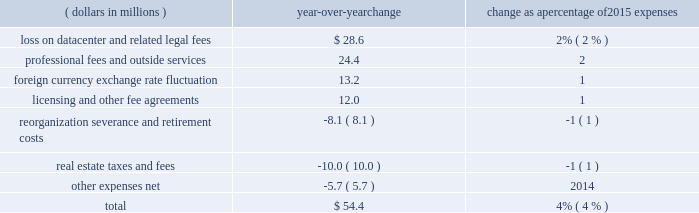Recognized total losses and expenses of $ 28.6 million , including a net loss on write-down to fair value of the assets and certain other transaction fees of $ 27.1 million within other expenses and $ 1.5 million of legal and other fees .
2022 professional fees and outside services expense decreased in 2017 compared to 2016 , largely due to higher legal and regulatory fees in 2016 related to our business activities and product offerings as well as higher professional fees related to a greater reliance on consultants for security and systems enhancement work .
The overall decrease in operating expenses in 2017 when compared with 2016 was partially offset by the following increases : 2022 licensing and other fee sharing agreements expense increased due to higher expense resulting from incentive payments made to facilitate the transition of the russell contract open interest , as well as increased costs of revenue sharing agreements for certain licensed products .
The overall increase in 2017 was partially offset by lower expense related to revenue sharing agreements for certain equity and energy contracts due to lower volume for these products compared to 2016 .
2022 compensation and benefits expense increased as a result of higher average headcount primarily in our international locations as well as normal cost of living adjustments .
2016 compared with 2015 operating expenses increased by $ 54.4 million in 2016 when compared with 2015 .
The table shows the estimated impact of key factors resulting in the net decrease in operating expenses .
( dollars in millions ) over-year change change as a percentage of 2015 expenses .
Overall operating expenses increased in 2016 when compared with 2015 due to the following reasons : 2022 in 2016 , we recognized total losses and expenses of $ 28.6 million , including a net loss on write-down to fair value of the assets and certain other transaction fees of $ 27.1 million within other expenses and $ 1.5 million of legal and other fees as a result of our sale and leaseback of our datacenter .
2022 professional fees and outside services expense increased in 2016 largely due to an increase in legal and regulatory efforts related to our business activities and product offerings as well as an increase in professional fees related to a greater reliance on consultants for security and systems enhancement work .
2022 in 2016 , we recognized a net loss of $ 24.5 million due to an unfavorable change in exchange rates on foreign cash balances , compared with a net loss of $ 11.3 million in 2015 .
2022 licensing and other fee sharing agreements expense increased due to higher expense related to revenue sharing agreements for certain equity and energy contracts due to both higher volume and an increase in license rates for certain equity and energy products. .
The loss on datacenter and related legal fees are how much of the total year over year change in expenses? 
Computations: (28.6 / 54.4)
Answer: 0.52574. Recognized total losses and expenses of $ 28.6 million , including a net loss on write-down to fair value of the assets and certain other transaction fees of $ 27.1 million within other expenses and $ 1.5 million of legal and other fees .
2022 professional fees and outside services expense decreased in 2017 compared to 2016 , largely due to higher legal and regulatory fees in 2016 related to our business activities and product offerings as well as higher professional fees related to a greater reliance on consultants for security and systems enhancement work .
The overall decrease in operating expenses in 2017 when compared with 2016 was partially offset by the following increases : 2022 licensing and other fee sharing agreements expense increased due to higher expense resulting from incentive payments made to facilitate the transition of the russell contract open interest , as well as increased costs of revenue sharing agreements for certain licensed products .
The overall increase in 2017 was partially offset by lower expense related to revenue sharing agreements for certain equity and energy contracts due to lower volume for these products compared to 2016 .
2022 compensation and benefits expense increased as a result of higher average headcount primarily in our international locations as well as normal cost of living adjustments .
2016 compared with 2015 operating expenses increased by $ 54.4 million in 2016 when compared with 2015 .
The table shows the estimated impact of key factors resulting in the net decrease in operating expenses .
( dollars in millions ) over-year change change as a percentage of 2015 expenses .
Overall operating expenses increased in 2016 when compared with 2015 due to the following reasons : 2022 in 2016 , we recognized total losses and expenses of $ 28.6 million , including a net loss on write-down to fair value of the assets and certain other transaction fees of $ 27.1 million within other expenses and $ 1.5 million of legal and other fees as a result of our sale and leaseback of our datacenter .
2022 professional fees and outside services expense increased in 2016 largely due to an increase in legal and regulatory efforts related to our business activities and product offerings as well as an increase in professional fees related to a greater reliance on consultants for security and systems enhancement work .
2022 in 2016 , we recognized a net loss of $ 24.5 million due to an unfavorable change in exchange rates on foreign cash balances , compared with a net loss of $ 11.3 million in 2015 .
2022 licensing and other fee sharing agreements expense increased due to higher expense related to revenue sharing agreements for certain equity and energy contracts due to both higher volume and an increase in license rates for certain equity and energy products. .
Increased license costs are how much of the total year over year cost increases? 
Computations: (12.0 / 54.4)
Answer: 0.22059. Recognized total losses and expenses of $ 28.6 million , including a net loss on write-down to fair value of the assets and certain other transaction fees of $ 27.1 million within other expenses and $ 1.5 million of legal and other fees .
2022 professional fees and outside services expense decreased in 2017 compared to 2016 , largely due to higher legal and regulatory fees in 2016 related to our business activities and product offerings as well as higher professional fees related to a greater reliance on consultants for security and systems enhancement work .
The overall decrease in operating expenses in 2017 when compared with 2016 was partially offset by the following increases : 2022 licensing and other fee sharing agreements expense increased due to higher expense resulting from incentive payments made to facilitate the transition of the russell contract open interest , as well as increased costs of revenue sharing agreements for certain licensed products .
The overall increase in 2017 was partially offset by lower expense related to revenue sharing agreements for certain equity and energy contracts due to lower volume for these products compared to 2016 .
2022 compensation and benefits expense increased as a result of higher average headcount primarily in our international locations as well as normal cost of living adjustments .
2016 compared with 2015 operating expenses increased by $ 54.4 million in 2016 when compared with 2015 .
The table shows the estimated impact of key factors resulting in the net decrease in operating expenses .
( dollars in millions ) over-year change change as a percentage of 2015 expenses .
Overall operating expenses increased in 2016 when compared with 2015 due to the following reasons : 2022 in 2016 , we recognized total losses and expenses of $ 28.6 million , including a net loss on write-down to fair value of the assets and certain other transaction fees of $ 27.1 million within other expenses and $ 1.5 million of legal and other fees as a result of our sale and leaseback of our datacenter .
2022 professional fees and outside services expense increased in 2016 largely due to an increase in legal and regulatory efforts related to our business activities and product offerings as well as an increase in professional fees related to a greater reliance on consultants for security and systems enhancement work .
2022 in 2016 , we recognized a net loss of $ 24.5 million due to an unfavorable change in exchange rates on foreign cash balances , compared with a net loss of $ 11.3 million in 2015 .
2022 licensing and other fee sharing agreements expense increased due to higher expense related to revenue sharing agreements for certain equity and energy contracts due to both higher volume and an increase in license rates for certain equity and energy products. .
How much was the total operating expenses in 2016 in millions of dollars? 
Rationale: considering the increase of $ 544 as a 4% variation , the original value is calculated dividing $ 54.4 by its percentage , then adding the original value plus the variation .
Computations: ((54.4 / 4%) + 54.4)
Answer: 1414.4. Recognized total losses and expenses of $ 28.6 million , including a net loss on write-down to fair value of the assets and certain other transaction fees of $ 27.1 million within other expenses and $ 1.5 million of legal and other fees .
2022 professional fees and outside services expense decreased in 2017 compared to 2016 , largely due to higher legal and regulatory fees in 2016 related to our business activities and product offerings as well as higher professional fees related to a greater reliance on consultants for security and systems enhancement work .
The overall decrease in operating expenses in 2017 when compared with 2016 was partially offset by the following increases : 2022 licensing and other fee sharing agreements expense increased due to higher expense resulting from incentive payments made to facilitate the transition of the russell contract open interest , as well as increased costs of revenue sharing agreements for certain licensed products .
The overall increase in 2017 was partially offset by lower expense related to revenue sharing agreements for certain equity and energy contracts due to lower volume for these products compared to 2016 .
2022 compensation and benefits expense increased as a result of higher average headcount primarily in our international locations as well as normal cost of living adjustments .
2016 compared with 2015 operating expenses increased by $ 54.4 million in 2016 when compared with 2015 .
The table shows the estimated impact of key factors resulting in the net decrease in operating expenses .
( dollars in millions ) over-year change change as a percentage of 2015 expenses .
Overall operating expenses increased in 2016 when compared with 2015 due to the following reasons : 2022 in 2016 , we recognized total losses and expenses of $ 28.6 million , including a net loss on write-down to fair value of the assets and certain other transaction fees of $ 27.1 million within other expenses and $ 1.5 million of legal and other fees as a result of our sale and leaseback of our datacenter .
2022 professional fees and outside services expense increased in 2016 largely due to an increase in legal and regulatory efforts related to our business activities and product offerings as well as an increase in professional fees related to a greater reliance on consultants for security and systems enhancement work .
2022 in 2016 , we recognized a net loss of $ 24.5 million due to an unfavorable change in exchange rates on foreign cash balances , compared with a net loss of $ 11.3 million in 2015 .
2022 licensing and other fee sharing agreements expense increased due to higher expense related to revenue sharing agreements for certain equity and energy contracts due to both higher volume and an increase in license rates for certain equity and energy products. .
What was the percent of the professional fees and outside services as part of the total overall changes 24.4? 
Computations: (24.4 / 54.4)
Answer: 0.44853. 